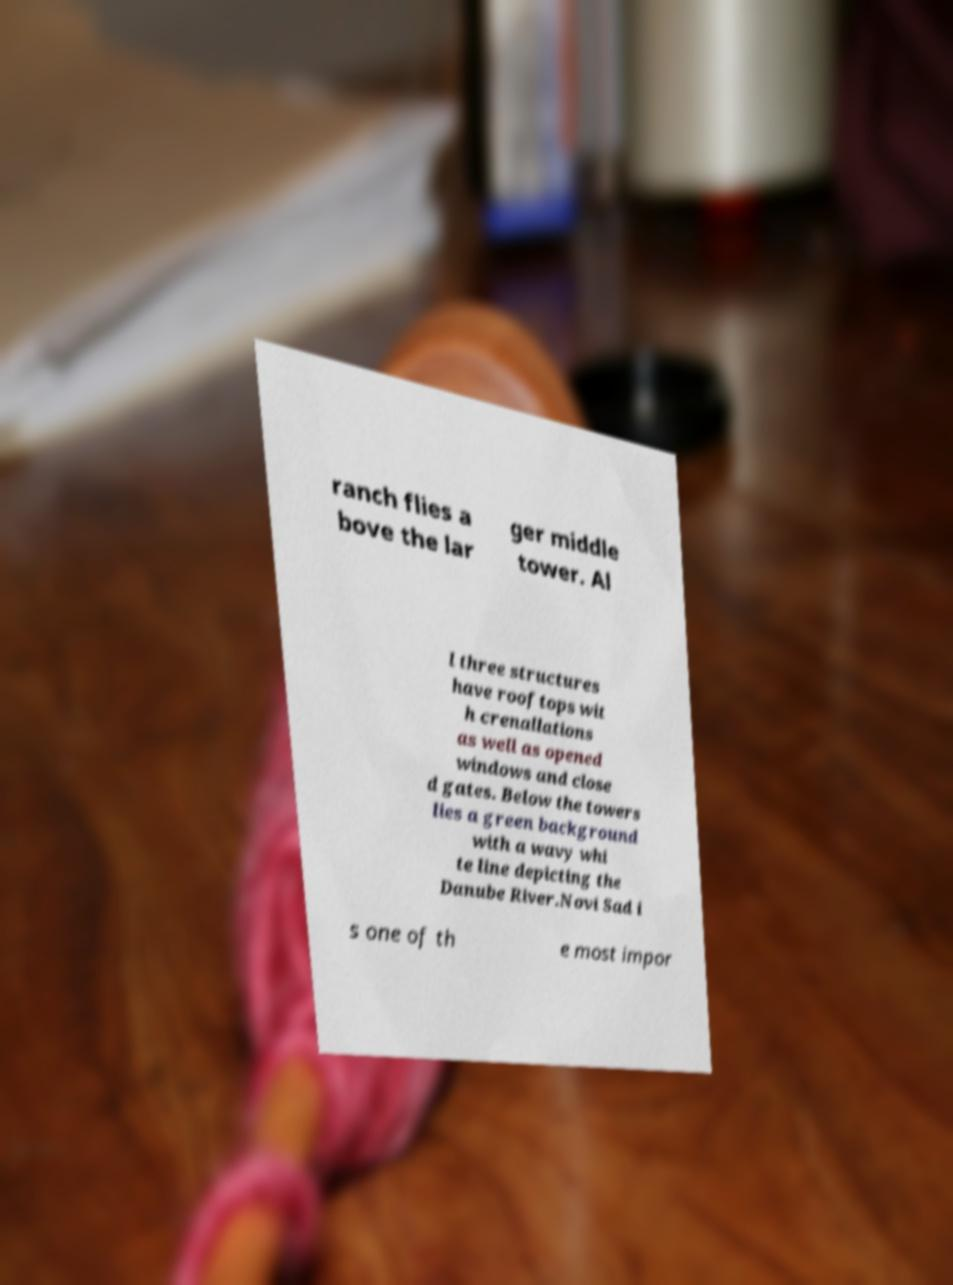Can you read and provide the text displayed in the image?This photo seems to have some interesting text. Can you extract and type it out for me? ranch flies a bove the lar ger middle tower. Al l three structures have rooftops wit h crenallations as well as opened windows and close d gates. Below the towers lies a green background with a wavy whi te line depicting the Danube River.Novi Sad i s one of th e most impor 